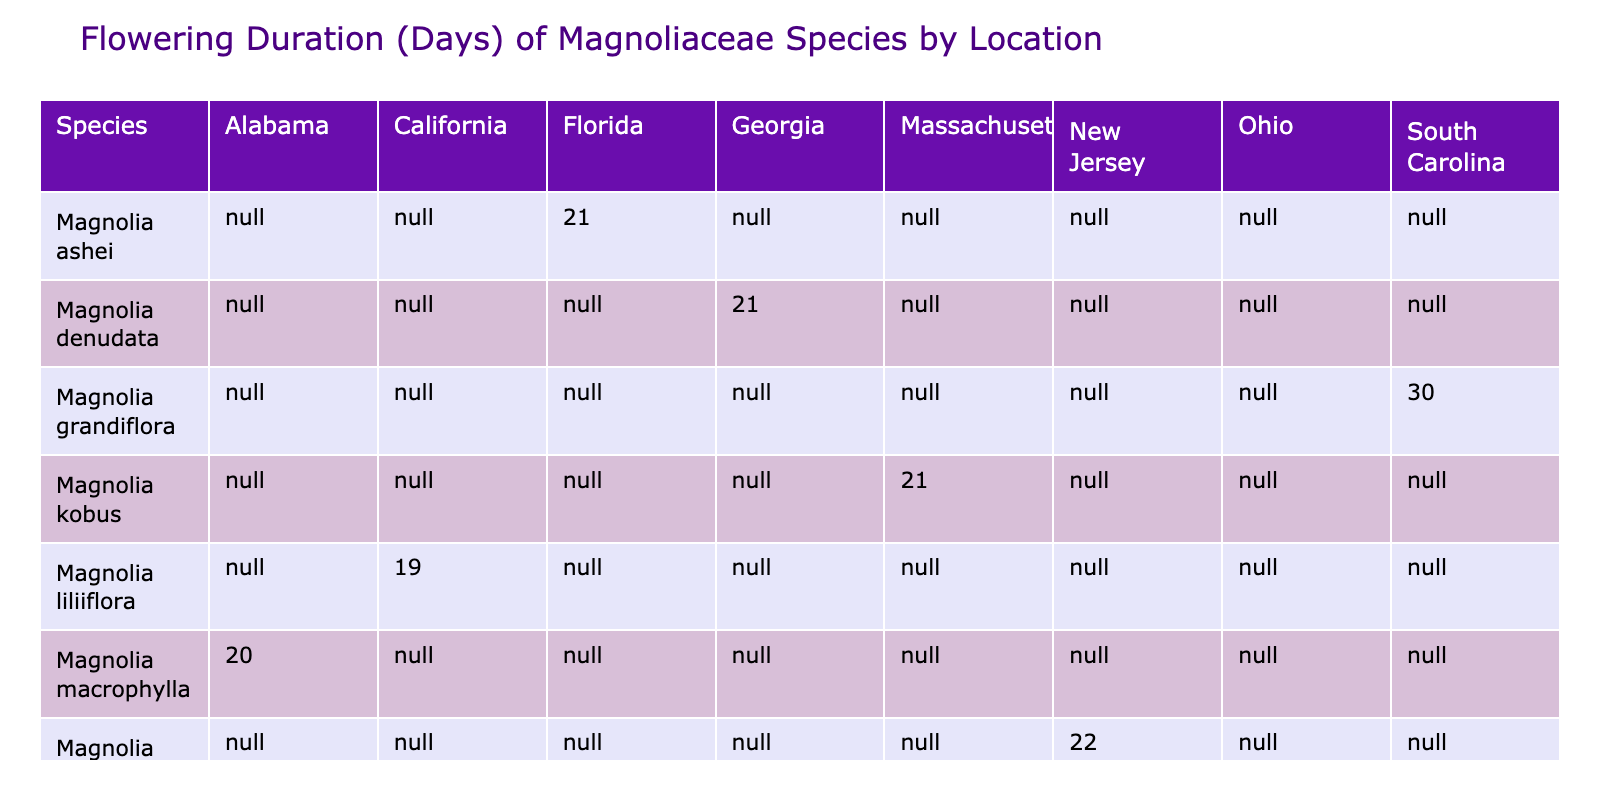What is the flowering duration for Magnolia grandiflora in South Carolina? The table shows that the flowering duration for Magnolia grandiflora in South Carolina is 30 days.
Answer: 30 days Which species has the shortest flowering duration, and how long is it? By inspecting the table, Magnolia liliiflora has the shortest flowering duration of 19 days.
Answer: 19 days Is there a species that blooms for 21 days in multiple locations? Yes, Magnolia denudata, Magnolia x soulangeana, and Magnolia kobus all have a flowering duration of 21 days in their respective locations.
Answer: Yes What is the average flowering duration of all species listed? The durations are 30, 22, 19, 21, 21, 21, 21, and 20 days. Adding these (30 + 22 + 19 + 21 + 21 + 21 + 21 + 20) gives  195 days. There are 8 species, so the average is 195 / 8 = 24.375 days.
Answer: 24.375 days Which species starts flowering first, and on what date does it begin? The earliest start date is for Magnolia stellata on March 10, 2023.
Answer: Magnolia stellata, March 10, 2023 How many species have a flowering duration longer than 20 days? The species with durations longer than 20 days are Magnolias grandiflora, denudata, ashei, and the three with 21 days. So, 5 species exceed this duration.
Answer: 5 species Is Magnolia macrophylla the only species that blooms in Alabama? Yes, according to the table, Magnolia macrophylla is the only species listed with a location in Alabama.
Answer: Yes What is the total duration of flowering for Magnolia ashei and Magnolia liliiflora combined? The flowering durations of Magnolia ashei (21 days) and Magnolia liliiflora (19 days) add up to 21 + 19 = 40 days.
Answer: 40 days Which species blooms for 20 days and in which state? Magnolia macrophylla blooms for 20 days in Alabama.
Answer: Magnolia macrophylla, Alabama 